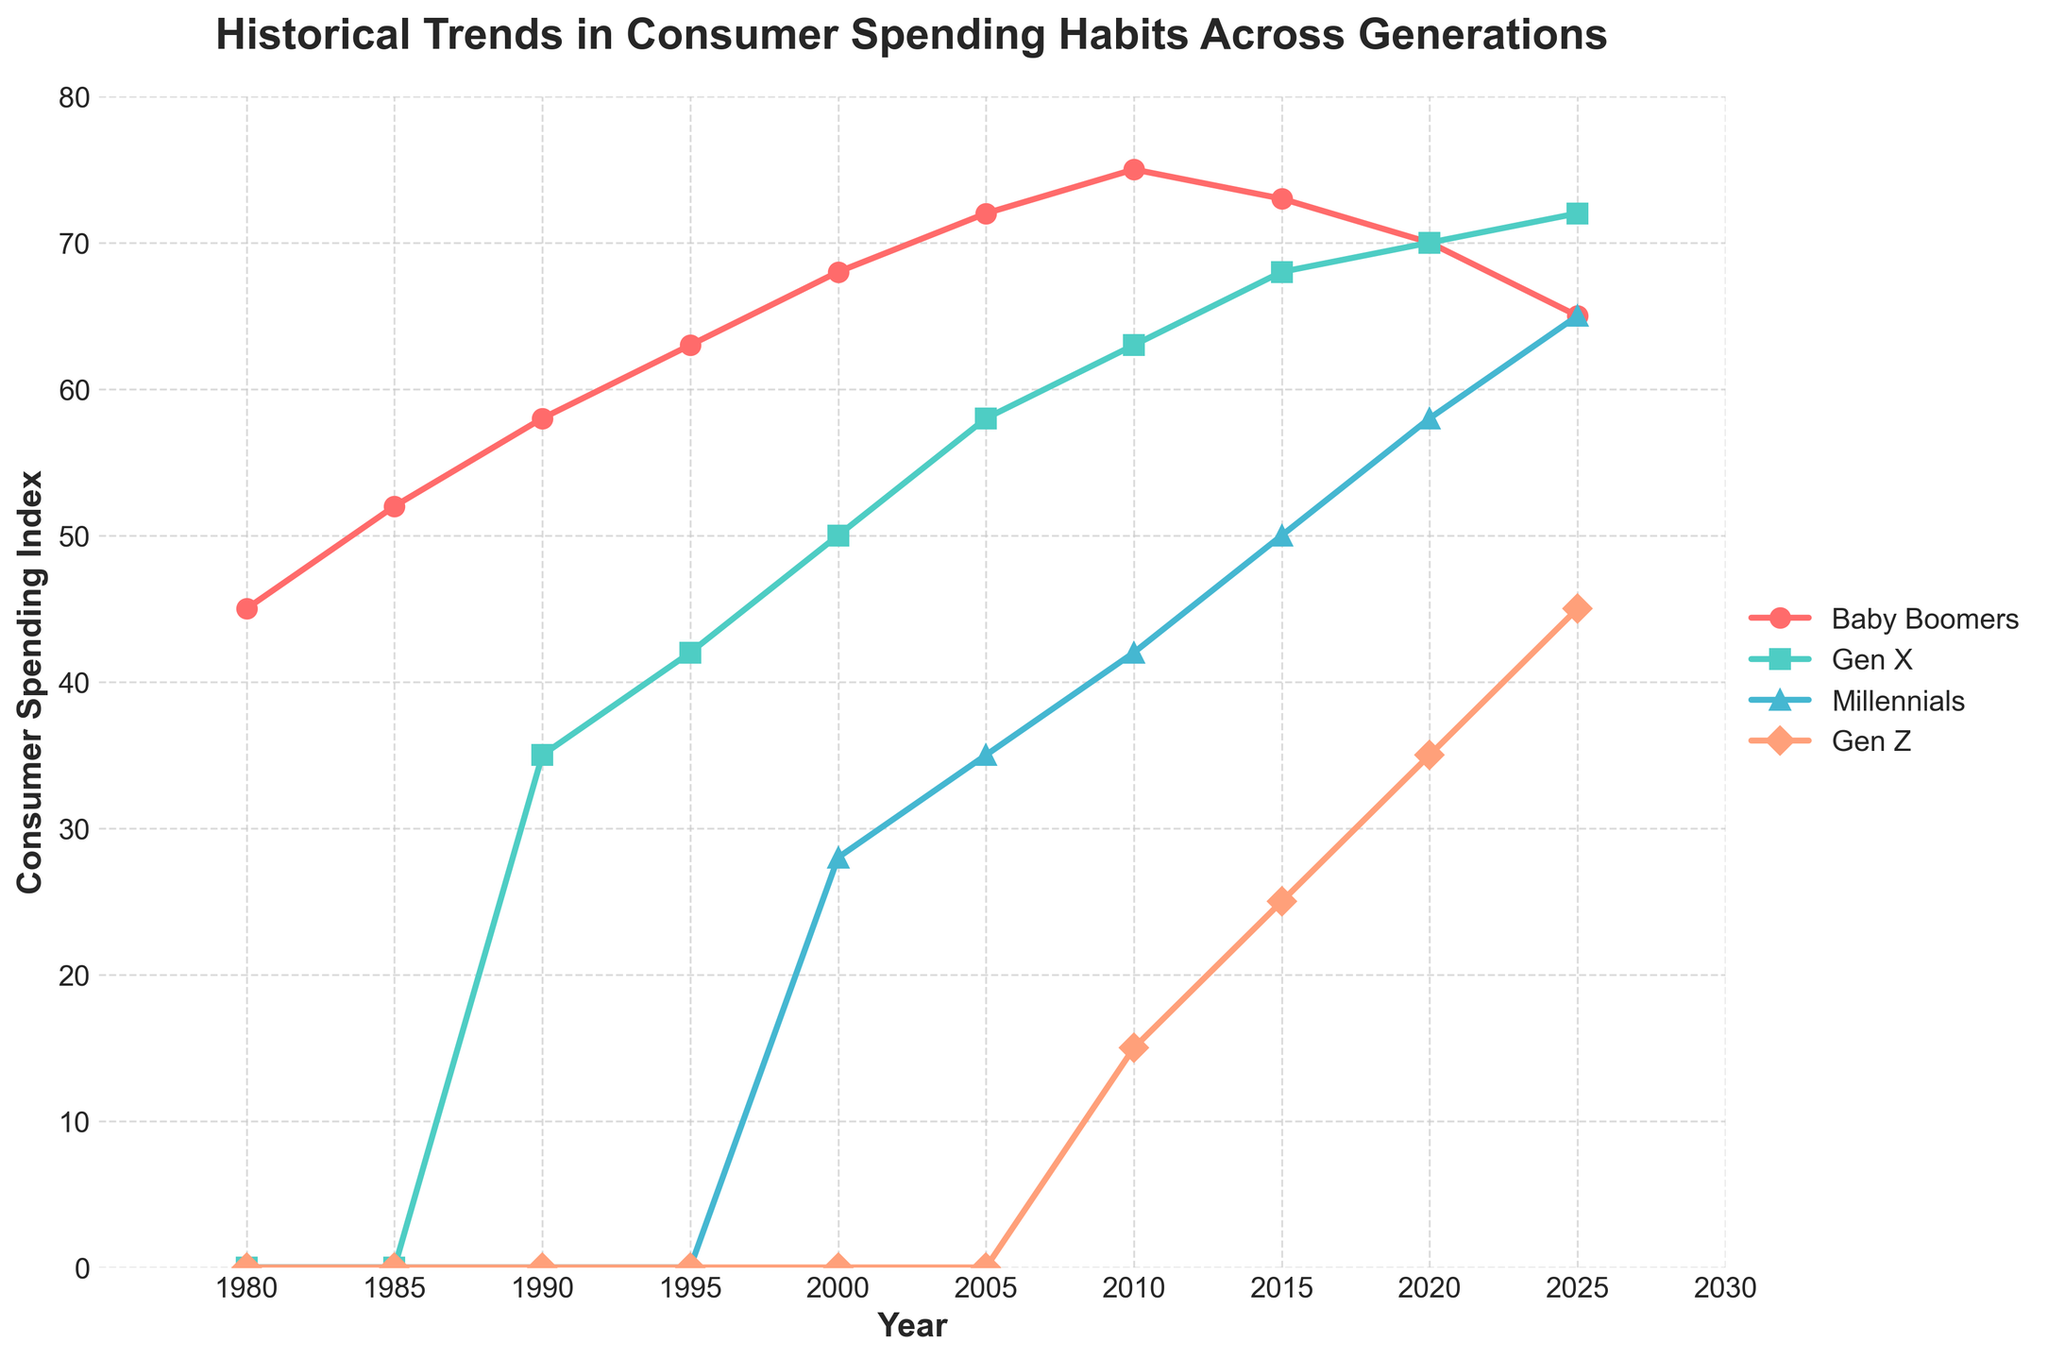Which generation had the highest consumer spending in 2000? Look at the year 2000 on the x-axis, and check the line that reaches the highest point for that year. The Baby Boomers line (red) is highest at 68.
Answer: Baby Boomers How did Gen X consumer spending change from 1990 to 2005? Look at the Gen X line (green) from 1990 to 2005. In 1990, it was at 35, and in 2005, it reached 58. The change is 58 - 35 = 23.
Answer: Increased by 23 Compare the spending trends of Millennials and Gen Z from 2010 to 2025. For Millennials (blue), check the starting point in 2010 (42) and ending point in 2025 (65). For Gen Z (orange), check the starting point in 2010 (15) and ending point in 2025 (45). Both generations show an increasing trend in spending. Millennials increase by 65 - 42 = 23, while Gen Z increases by 45 - 15 = 30.
Answer: Both increased; Millennials by 23, Gen Z by 30 Which generation shows a decline in consumer spending between 2015 and 2025? Look at each generation's lines between 2015 and 2025. The Baby Boomers’ line (red) drops from 73 to 65.
Answer: Baby Boomers What is the average consumer spending of Baby Boomers from 1980 to 2025? The values for Baby Boomers are: 45, 52, 58, 63, 68, 72, 75, 73, 70, and 65. Sum these values (45 + 52 + 58 + 63 + 68 + 72 + 75 + 73 + 70 + 65 = 641) and divide by the number of years (10). The average is 641 / 10 = 64.1.
Answer: 64.1 By how much did Gen Z's consumer spending increase from 2010 to 2020? Look at the points for Gen Z in 2010 (15) and 2020 (35). The increase is 35 - 15 = 20.
Answer: 20 Which generation had the most stable consumer spending trend from 1980 to 2025? Observe the slope of each generation's line. Gen X (green) shows a steady rise without significant fluctuations compared to other generations.
Answer: Gen X 